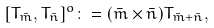<formula> <loc_0><loc_0><loc_500><loc_500>[ T _ { \bar { m } } , T _ { \bar { n } } ] ^ { o } \colon = ( \bar { m } \times \bar { n } ) T _ { \bar { m } + \bar { n } } ,</formula> 